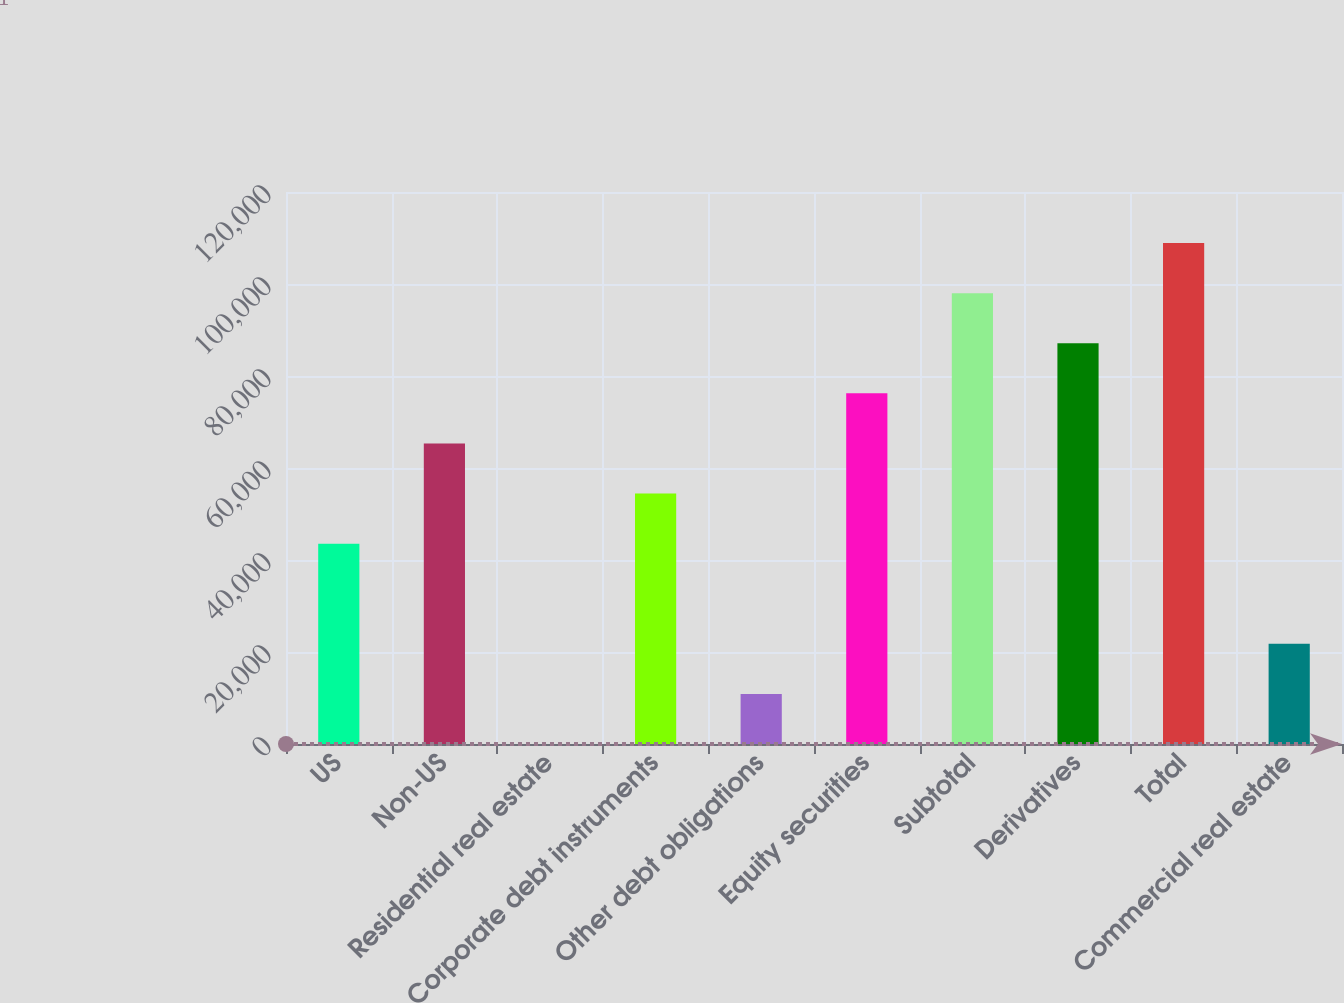Convert chart to OTSL. <chart><loc_0><loc_0><loc_500><loc_500><bar_chart><fcel>US<fcel>Non-US<fcel>Residential real estate<fcel>Corporate debt instruments<fcel>Other debt obligations<fcel>Equity securities<fcel>Subtotal<fcel>Derivatives<fcel>Total<fcel>Commercial real estate<nl><fcel>43559.4<fcel>65338.6<fcel>1<fcel>54449<fcel>10890.6<fcel>76228.2<fcel>98007.4<fcel>87117.8<fcel>108897<fcel>21780.2<nl></chart> 